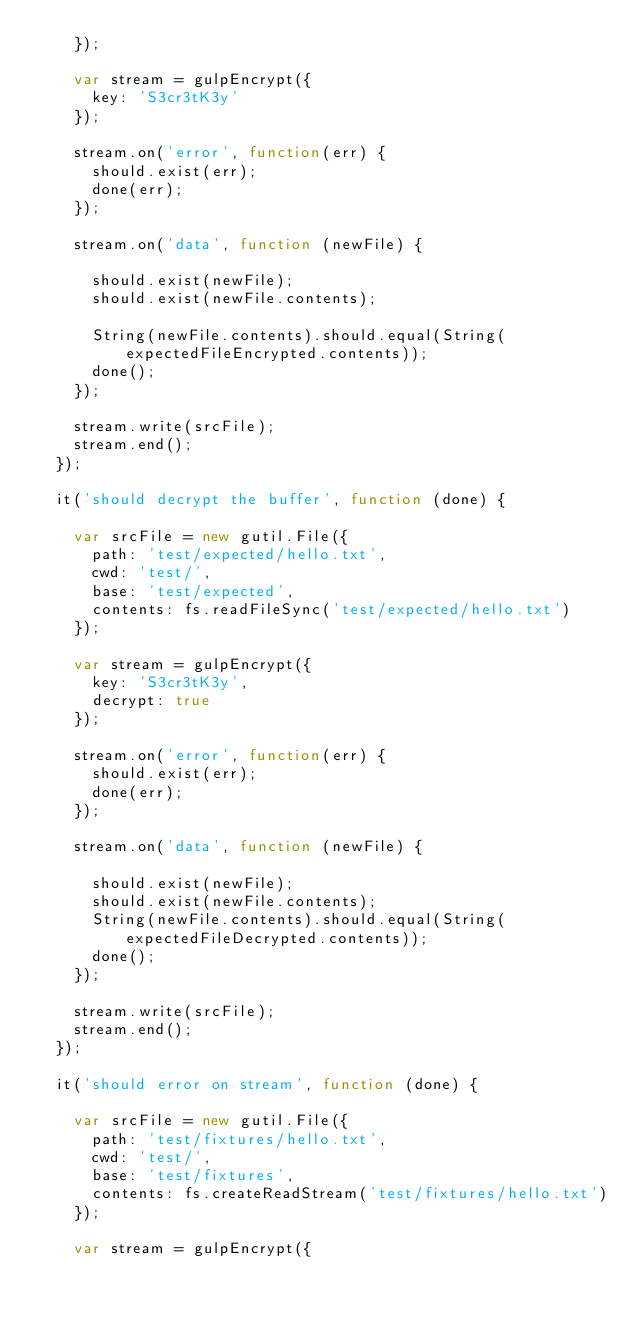Convert code to text. <code><loc_0><loc_0><loc_500><loc_500><_JavaScript_>		});

		var stream = gulpEncrypt({
			key: 'S3cr3tK3y'
		});

		stream.on('error', function(err) {
			should.exist(err);
			done(err);
		});

		stream.on('data', function (newFile) {

			should.exist(newFile);
			should.exist(newFile.contents);

			String(newFile.contents).should.equal(String(expectedFileEncrypted.contents));
			done();
		});

		stream.write(srcFile);
		stream.end();
	});

	it('should decrypt the buffer', function (done) {

		var srcFile = new gutil.File({
			path: 'test/expected/hello.txt',
			cwd: 'test/',
			base: 'test/expected',
			contents: fs.readFileSync('test/expected/hello.txt')
		});

		var stream = gulpEncrypt({
			key: 'S3cr3tK3y',
			decrypt: true
		});

		stream.on('error', function(err) {
			should.exist(err);
			done(err);
		});

		stream.on('data', function (newFile) {

			should.exist(newFile);
			should.exist(newFile.contents);
			String(newFile.contents).should.equal(String(expectedFileDecrypted.contents));
			done();
		});

		stream.write(srcFile);
		stream.end();
	});

	it('should error on stream', function (done) {

		var srcFile = new gutil.File({
			path: 'test/fixtures/hello.txt',
			cwd: 'test/',
			base: 'test/fixtures',
			contents: fs.createReadStream('test/fixtures/hello.txt')
		});

		var stream = gulpEncrypt({</code> 